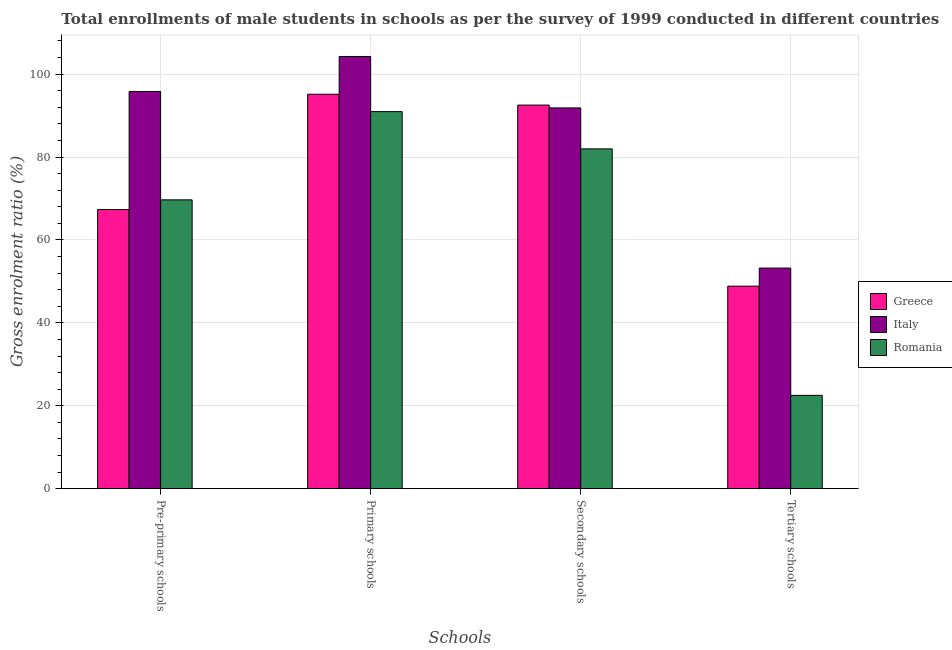How many groups of bars are there?
Your answer should be very brief. 4. Are the number of bars per tick equal to the number of legend labels?
Your answer should be compact. Yes. Are the number of bars on each tick of the X-axis equal?
Provide a short and direct response. Yes. How many bars are there on the 2nd tick from the right?
Make the answer very short. 3. What is the label of the 2nd group of bars from the left?
Provide a succinct answer. Primary schools. What is the gross enrolment ratio(male) in secondary schools in Romania?
Provide a short and direct response. 81.97. Across all countries, what is the maximum gross enrolment ratio(male) in pre-primary schools?
Make the answer very short. 95.82. Across all countries, what is the minimum gross enrolment ratio(male) in secondary schools?
Keep it short and to the point. 81.97. In which country was the gross enrolment ratio(male) in pre-primary schools maximum?
Ensure brevity in your answer.  Italy. In which country was the gross enrolment ratio(male) in tertiary schools minimum?
Make the answer very short. Romania. What is the total gross enrolment ratio(male) in tertiary schools in the graph?
Make the answer very short. 124.58. What is the difference between the gross enrolment ratio(male) in secondary schools in Romania and that in Italy?
Make the answer very short. -9.88. What is the difference between the gross enrolment ratio(male) in primary schools in Italy and the gross enrolment ratio(male) in pre-primary schools in Romania?
Make the answer very short. 34.59. What is the average gross enrolment ratio(male) in secondary schools per country?
Offer a very short reply. 88.79. What is the difference between the gross enrolment ratio(male) in tertiary schools and gross enrolment ratio(male) in primary schools in Romania?
Your answer should be very brief. -68.45. What is the ratio of the gross enrolment ratio(male) in pre-primary schools in Romania to that in Italy?
Ensure brevity in your answer.  0.73. Is the difference between the gross enrolment ratio(male) in tertiary schools in Romania and Italy greater than the difference between the gross enrolment ratio(male) in pre-primary schools in Romania and Italy?
Your answer should be compact. No. What is the difference between the highest and the second highest gross enrolment ratio(male) in tertiary schools?
Your answer should be compact. 4.36. What is the difference between the highest and the lowest gross enrolment ratio(male) in secondary schools?
Offer a terse response. 10.57. In how many countries, is the gross enrolment ratio(male) in primary schools greater than the average gross enrolment ratio(male) in primary schools taken over all countries?
Make the answer very short. 1. Is the sum of the gross enrolment ratio(male) in secondary schools in Italy and Romania greater than the maximum gross enrolment ratio(male) in pre-primary schools across all countries?
Offer a terse response. Yes. What does the 3rd bar from the right in Primary schools represents?
Offer a terse response. Greece. Is it the case that in every country, the sum of the gross enrolment ratio(male) in pre-primary schools and gross enrolment ratio(male) in primary schools is greater than the gross enrolment ratio(male) in secondary schools?
Make the answer very short. Yes. How many bars are there?
Give a very brief answer. 12. Are all the bars in the graph horizontal?
Ensure brevity in your answer.  No. How many countries are there in the graph?
Offer a terse response. 3. Does the graph contain grids?
Your answer should be very brief. Yes. Where does the legend appear in the graph?
Provide a succinct answer. Center right. What is the title of the graph?
Make the answer very short. Total enrollments of male students in schools as per the survey of 1999 conducted in different countries. Does "Latvia" appear as one of the legend labels in the graph?
Offer a terse response. No. What is the label or title of the X-axis?
Your answer should be very brief. Schools. What is the Gross enrolment ratio (%) in Greece in Pre-primary schools?
Keep it short and to the point. 67.35. What is the Gross enrolment ratio (%) in Italy in Pre-primary schools?
Make the answer very short. 95.82. What is the Gross enrolment ratio (%) in Romania in Pre-primary schools?
Ensure brevity in your answer.  69.67. What is the Gross enrolment ratio (%) in Greece in Primary schools?
Keep it short and to the point. 95.15. What is the Gross enrolment ratio (%) of Italy in Primary schools?
Your answer should be compact. 104.26. What is the Gross enrolment ratio (%) of Romania in Primary schools?
Your answer should be compact. 90.96. What is the Gross enrolment ratio (%) of Greece in Secondary schools?
Provide a short and direct response. 92.54. What is the Gross enrolment ratio (%) of Italy in Secondary schools?
Ensure brevity in your answer.  91.85. What is the Gross enrolment ratio (%) in Romania in Secondary schools?
Offer a terse response. 81.97. What is the Gross enrolment ratio (%) in Greece in Tertiary schools?
Give a very brief answer. 48.86. What is the Gross enrolment ratio (%) of Italy in Tertiary schools?
Ensure brevity in your answer.  53.22. What is the Gross enrolment ratio (%) of Romania in Tertiary schools?
Your response must be concise. 22.51. Across all Schools, what is the maximum Gross enrolment ratio (%) of Greece?
Keep it short and to the point. 95.15. Across all Schools, what is the maximum Gross enrolment ratio (%) in Italy?
Make the answer very short. 104.26. Across all Schools, what is the maximum Gross enrolment ratio (%) of Romania?
Provide a short and direct response. 90.96. Across all Schools, what is the minimum Gross enrolment ratio (%) of Greece?
Ensure brevity in your answer.  48.86. Across all Schools, what is the minimum Gross enrolment ratio (%) in Italy?
Your answer should be very brief. 53.22. Across all Schools, what is the minimum Gross enrolment ratio (%) of Romania?
Keep it short and to the point. 22.51. What is the total Gross enrolment ratio (%) in Greece in the graph?
Your answer should be compact. 303.89. What is the total Gross enrolment ratio (%) of Italy in the graph?
Offer a very short reply. 345.15. What is the total Gross enrolment ratio (%) in Romania in the graph?
Offer a very short reply. 265.12. What is the difference between the Gross enrolment ratio (%) in Greece in Pre-primary schools and that in Primary schools?
Provide a short and direct response. -27.81. What is the difference between the Gross enrolment ratio (%) of Italy in Pre-primary schools and that in Primary schools?
Provide a succinct answer. -8.44. What is the difference between the Gross enrolment ratio (%) of Romania in Pre-primary schools and that in Primary schools?
Make the answer very short. -21.29. What is the difference between the Gross enrolment ratio (%) in Greece in Pre-primary schools and that in Secondary schools?
Offer a very short reply. -25.19. What is the difference between the Gross enrolment ratio (%) in Italy in Pre-primary schools and that in Secondary schools?
Your answer should be compact. 3.97. What is the difference between the Gross enrolment ratio (%) of Romania in Pre-primary schools and that in Secondary schools?
Offer a terse response. -12.3. What is the difference between the Gross enrolment ratio (%) of Greece in Pre-primary schools and that in Tertiary schools?
Offer a terse response. 18.49. What is the difference between the Gross enrolment ratio (%) of Italy in Pre-primary schools and that in Tertiary schools?
Keep it short and to the point. 42.61. What is the difference between the Gross enrolment ratio (%) in Romania in Pre-primary schools and that in Tertiary schools?
Give a very brief answer. 47.16. What is the difference between the Gross enrolment ratio (%) in Greece in Primary schools and that in Secondary schools?
Your answer should be very brief. 2.62. What is the difference between the Gross enrolment ratio (%) in Italy in Primary schools and that in Secondary schools?
Your response must be concise. 12.41. What is the difference between the Gross enrolment ratio (%) of Romania in Primary schools and that in Secondary schools?
Your response must be concise. 8.99. What is the difference between the Gross enrolment ratio (%) of Greece in Primary schools and that in Tertiary schools?
Offer a very short reply. 46.3. What is the difference between the Gross enrolment ratio (%) in Italy in Primary schools and that in Tertiary schools?
Keep it short and to the point. 51.04. What is the difference between the Gross enrolment ratio (%) of Romania in Primary schools and that in Tertiary schools?
Your answer should be compact. 68.45. What is the difference between the Gross enrolment ratio (%) of Greece in Secondary schools and that in Tertiary schools?
Provide a succinct answer. 43.68. What is the difference between the Gross enrolment ratio (%) in Italy in Secondary schools and that in Tertiary schools?
Give a very brief answer. 38.64. What is the difference between the Gross enrolment ratio (%) in Romania in Secondary schools and that in Tertiary schools?
Keep it short and to the point. 59.46. What is the difference between the Gross enrolment ratio (%) of Greece in Pre-primary schools and the Gross enrolment ratio (%) of Italy in Primary schools?
Your answer should be compact. -36.91. What is the difference between the Gross enrolment ratio (%) in Greece in Pre-primary schools and the Gross enrolment ratio (%) in Romania in Primary schools?
Provide a succinct answer. -23.61. What is the difference between the Gross enrolment ratio (%) in Italy in Pre-primary schools and the Gross enrolment ratio (%) in Romania in Primary schools?
Your answer should be very brief. 4.86. What is the difference between the Gross enrolment ratio (%) of Greece in Pre-primary schools and the Gross enrolment ratio (%) of Italy in Secondary schools?
Make the answer very short. -24.51. What is the difference between the Gross enrolment ratio (%) of Greece in Pre-primary schools and the Gross enrolment ratio (%) of Romania in Secondary schools?
Ensure brevity in your answer.  -14.62. What is the difference between the Gross enrolment ratio (%) of Italy in Pre-primary schools and the Gross enrolment ratio (%) of Romania in Secondary schools?
Your response must be concise. 13.85. What is the difference between the Gross enrolment ratio (%) in Greece in Pre-primary schools and the Gross enrolment ratio (%) in Italy in Tertiary schools?
Your response must be concise. 14.13. What is the difference between the Gross enrolment ratio (%) of Greece in Pre-primary schools and the Gross enrolment ratio (%) of Romania in Tertiary schools?
Your answer should be compact. 44.84. What is the difference between the Gross enrolment ratio (%) in Italy in Pre-primary schools and the Gross enrolment ratio (%) in Romania in Tertiary schools?
Keep it short and to the point. 73.31. What is the difference between the Gross enrolment ratio (%) in Greece in Primary schools and the Gross enrolment ratio (%) in Italy in Secondary schools?
Keep it short and to the point. 3.3. What is the difference between the Gross enrolment ratio (%) in Greece in Primary schools and the Gross enrolment ratio (%) in Romania in Secondary schools?
Your answer should be very brief. 13.18. What is the difference between the Gross enrolment ratio (%) in Italy in Primary schools and the Gross enrolment ratio (%) in Romania in Secondary schools?
Your answer should be very brief. 22.29. What is the difference between the Gross enrolment ratio (%) in Greece in Primary schools and the Gross enrolment ratio (%) in Italy in Tertiary schools?
Your response must be concise. 41.94. What is the difference between the Gross enrolment ratio (%) of Greece in Primary schools and the Gross enrolment ratio (%) of Romania in Tertiary schools?
Ensure brevity in your answer.  72.64. What is the difference between the Gross enrolment ratio (%) in Italy in Primary schools and the Gross enrolment ratio (%) in Romania in Tertiary schools?
Offer a very short reply. 81.75. What is the difference between the Gross enrolment ratio (%) in Greece in Secondary schools and the Gross enrolment ratio (%) in Italy in Tertiary schools?
Your answer should be very brief. 39.32. What is the difference between the Gross enrolment ratio (%) in Greece in Secondary schools and the Gross enrolment ratio (%) in Romania in Tertiary schools?
Keep it short and to the point. 70.02. What is the difference between the Gross enrolment ratio (%) in Italy in Secondary schools and the Gross enrolment ratio (%) in Romania in Tertiary schools?
Keep it short and to the point. 69.34. What is the average Gross enrolment ratio (%) in Greece per Schools?
Keep it short and to the point. 75.97. What is the average Gross enrolment ratio (%) of Italy per Schools?
Your answer should be compact. 86.29. What is the average Gross enrolment ratio (%) in Romania per Schools?
Your response must be concise. 66.28. What is the difference between the Gross enrolment ratio (%) in Greece and Gross enrolment ratio (%) in Italy in Pre-primary schools?
Ensure brevity in your answer.  -28.48. What is the difference between the Gross enrolment ratio (%) of Greece and Gross enrolment ratio (%) of Romania in Pre-primary schools?
Give a very brief answer. -2.33. What is the difference between the Gross enrolment ratio (%) of Italy and Gross enrolment ratio (%) of Romania in Pre-primary schools?
Provide a short and direct response. 26.15. What is the difference between the Gross enrolment ratio (%) in Greece and Gross enrolment ratio (%) in Italy in Primary schools?
Ensure brevity in your answer.  -9.11. What is the difference between the Gross enrolment ratio (%) of Greece and Gross enrolment ratio (%) of Romania in Primary schools?
Your answer should be very brief. 4.19. What is the difference between the Gross enrolment ratio (%) of Italy and Gross enrolment ratio (%) of Romania in Primary schools?
Offer a very short reply. 13.3. What is the difference between the Gross enrolment ratio (%) in Greece and Gross enrolment ratio (%) in Italy in Secondary schools?
Make the answer very short. 0.68. What is the difference between the Gross enrolment ratio (%) of Greece and Gross enrolment ratio (%) of Romania in Secondary schools?
Give a very brief answer. 10.57. What is the difference between the Gross enrolment ratio (%) of Italy and Gross enrolment ratio (%) of Romania in Secondary schools?
Your answer should be compact. 9.88. What is the difference between the Gross enrolment ratio (%) in Greece and Gross enrolment ratio (%) in Italy in Tertiary schools?
Keep it short and to the point. -4.36. What is the difference between the Gross enrolment ratio (%) of Greece and Gross enrolment ratio (%) of Romania in Tertiary schools?
Give a very brief answer. 26.34. What is the difference between the Gross enrolment ratio (%) in Italy and Gross enrolment ratio (%) in Romania in Tertiary schools?
Offer a terse response. 30.71. What is the ratio of the Gross enrolment ratio (%) in Greece in Pre-primary schools to that in Primary schools?
Give a very brief answer. 0.71. What is the ratio of the Gross enrolment ratio (%) in Italy in Pre-primary schools to that in Primary schools?
Keep it short and to the point. 0.92. What is the ratio of the Gross enrolment ratio (%) in Romania in Pre-primary schools to that in Primary schools?
Offer a very short reply. 0.77. What is the ratio of the Gross enrolment ratio (%) in Greece in Pre-primary schools to that in Secondary schools?
Ensure brevity in your answer.  0.73. What is the ratio of the Gross enrolment ratio (%) of Italy in Pre-primary schools to that in Secondary schools?
Your answer should be very brief. 1.04. What is the ratio of the Gross enrolment ratio (%) in Romania in Pre-primary schools to that in Secondary schools?
Your response must be concise. 0.85. What is the ratio of the Gross enrolment ratio (%) of Greece in Pre-primary schools to that in Tertiary schools?
Ensure brevity in your answer.  1.38. What is the ratio of the Gross enrolment ratio (%) in Italy in Pre-primary schools to that in Tertiary schools?
Make the answer very short. 1.8. What is the ratio of the Gross enrolment ratio (%) of Romania in Pre-primary schools to that in Tertiary schools?
Your answer should be compact. 3.1. What is the ratio of the Gross enrolment ratio (%) in Greece in Primary schools to that in Secondary schools?
Provide a succinct answer. 1.03. What is the ratio of the Gross enrolment ratio (%) of Italy in Primary schools to that in Secondary schools?
Offer a very short reply. 1.14. What is the ratio of the Gross enrolment ratio (%) in Romania in Primary schools to that in Secondary schools?
Give a very brief answer. 1.11. What is the ratio of the Gross enrolment ratio (%) in Greece in Primary schools to that in Tertiary schools?
Keep it short and to the point. 1.95. What is the ratio of the Gross enrolment ratio (%) in Italy in Primary schools to that in Tertiary schools?
Make the answer very short. 1.96. What is the ratio of the Gross enrolment ratio (%) in Romania in Primary schools to that in Tertiary schools?
Ensure brevity in your answer.  4.04. What is the ratio of the Gross enrolment ratio (%) of Greece in Secondary schools to that in Tertiary schools?
Give a very brief answer. 1.89. What is the ratio of the Gross enrolment ratio (%) in Italy in Secondary schools to that in Tertiary schools?
Your answer should be very brief. 1.73. What is the ratio of the Gross enrolment ratio (%) of Romania in Secondary schools to that in Tertiary schools?
Make the answer very short. 3.64. What is the difference between the highest and the second highest Gross enrolment ratio (%) of Greece?
Offer a terse response. 2.62. What is the difference between the highest and the second highest Gross enrolment ratio (%) of Italy?
Your answer should be very brief. 8.44. What is the difference between the highest and the second highest Gross enrolment ratio (%) in Romania?
Provide a succinct answer. 8.99. What is the difference between the highest and the lowest Gross enrolment ratio (%) of Greece?
Offer a terse response. 46.3. What is the difference between the highest and the lowest Gross enrolment ratio (%) of Italy?
Your response must be concise. 51.04. What is the difference between the highest and the lowest Gross enrolment ratio (%) of Romania?
Offer a very short reply. 68.45. 